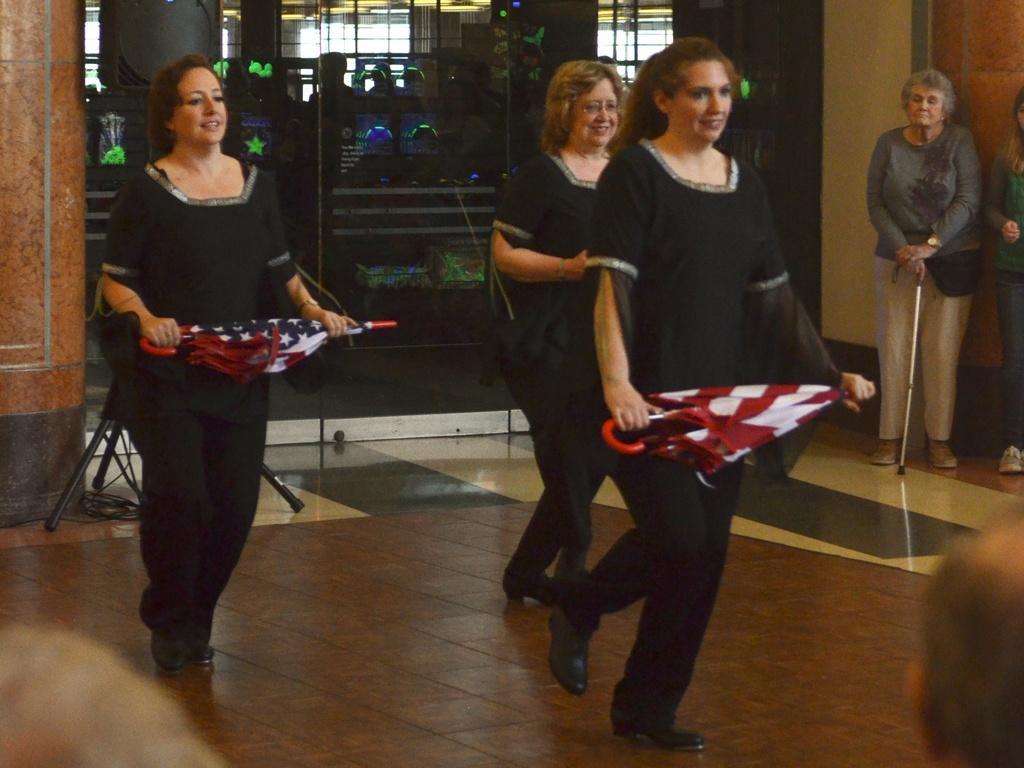Describe this image in one or two sentences. In the image there are three women in black uniform holding umbrella and dancing on the floor and in the back there are two women standing in front of the wall and behind them there is glass wall. 